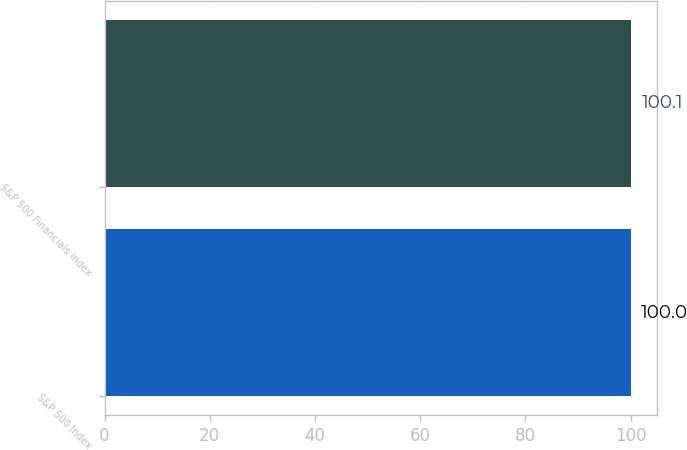Convert chart to OTSL. <chart><loc_0><loc_0><loc_500><loc_500><bar_chart><fcel>S&P 500 Index<fcel>S&P 500 Financials Index<nl><fcel>100<fcel>100.1<nl></chart> 